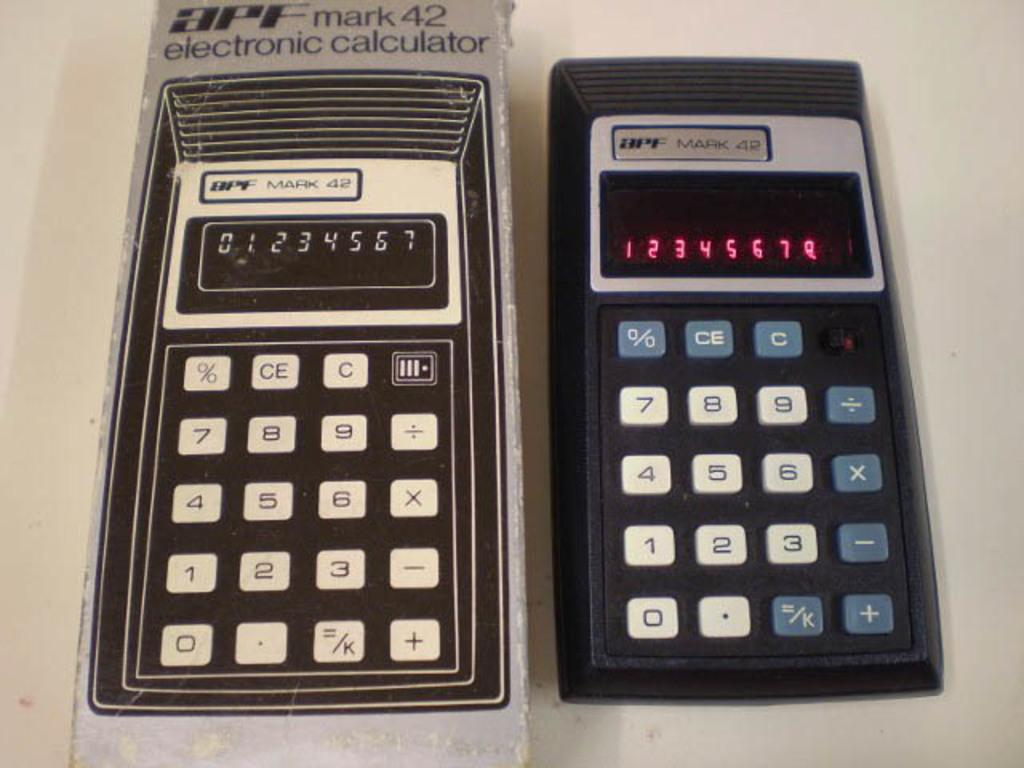<image>
Describe the image concisely. APF mark 42 electronic calculator displayed next to it's original packaging. 